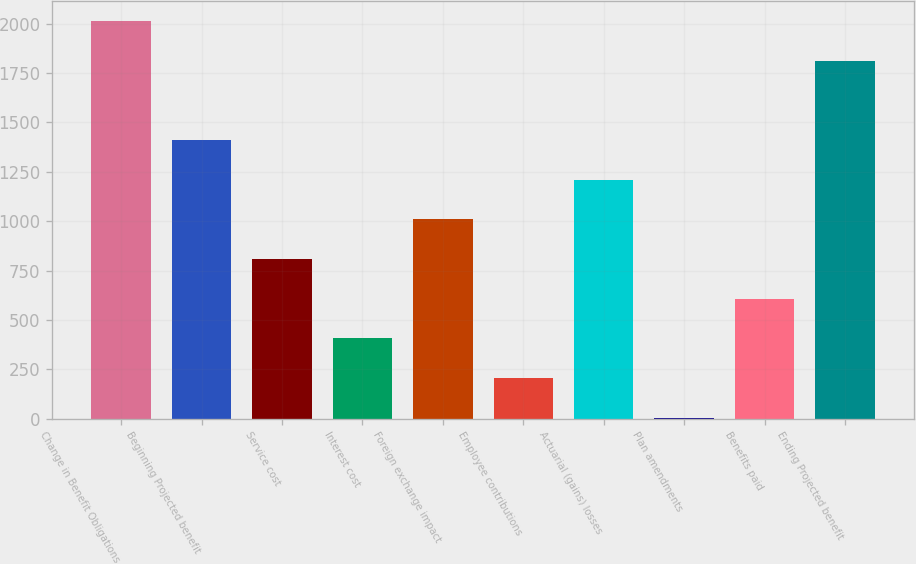Convert chart. <chart><loc_0><loc_0><loc_500><loc_500><bar_chart><fcel>Change in Benefit Obligations<fcel>Beginning Projected benefit<fcel>Service cost<fcel>Interest cost<fcel>Foreign exchange impact<fcel>Employee contributions<fcel>Actuarial (gains) losses<fcel>Plan amendments<fcel>Benefits paid<fcel>Ending Projected benefit<nl><fcel>2014<fcel>1411.3<fcel>808.6<fcel>406.8<fcel>1009.5<fcel>205.9<fcel>1210.4<fcel>5<fcel>607.7<fcel>1813.1<nl></chart> 